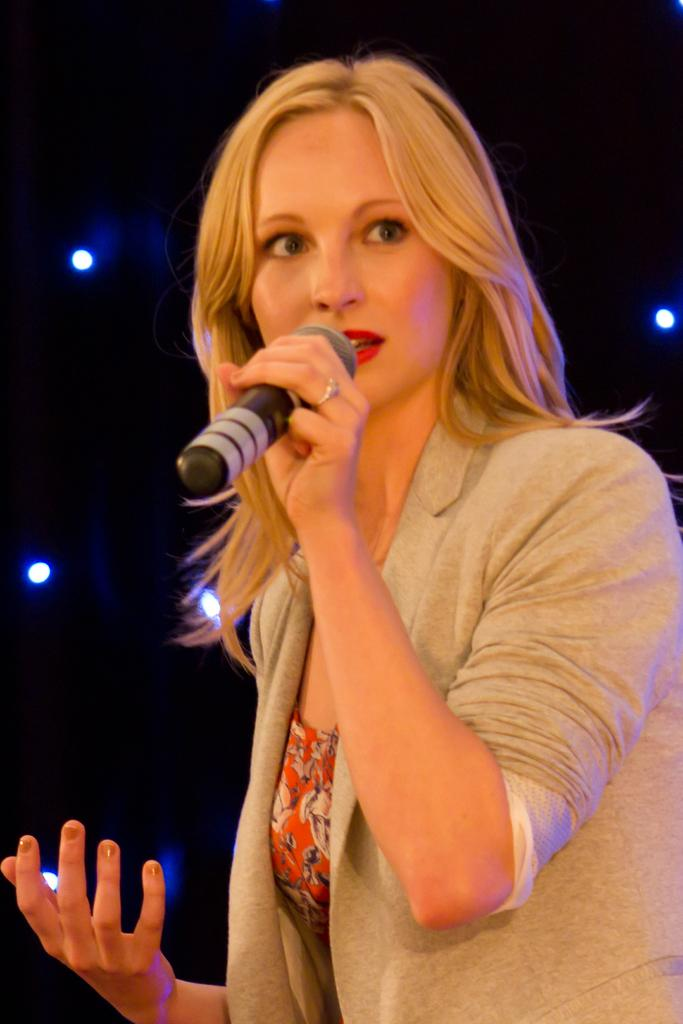Who is the main subject in the image? There is a woman in the image. What is the woman holding in the image? The woman is holding a microphone. What can be seen in the background of the image? There are lights visible in the background of the image. What is the color of the background in the image? The background of the image is black. What type of page is the woman turning in the image? There is no page present in the image; the woman is holding a microphone. Can you hear the woman laughing in the image? The image is a still picture, so it does not capture any sound, including laughter. 